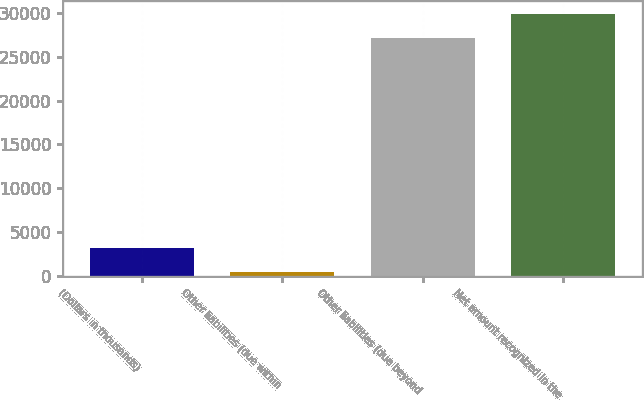Convert chart to OTSL. <chart><loc_0><loc_0><loc_500><loc_500><bar_chart><fcel>(Dollars in thousands)<fcel>Other liabilities (due within<fcel>Other liabilities (due beyond<fcel>Net amount recognized in the<nl><fcel>3176.1<fcel>463<fcel>27130<fcel>29843.1<nl></chart> 